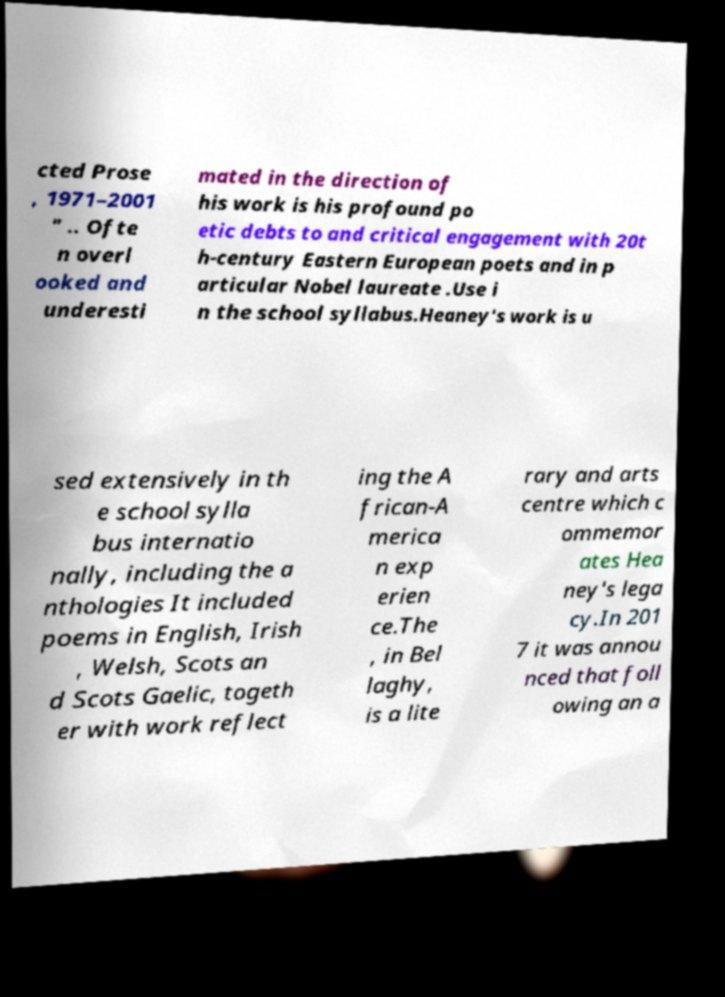Could you extract and type out the text from this image? cted Prose , 1971–2001 " .. Ofte n overl ooked and underesti mated in the direction of his work is his profound po etic debts to and critical engagement with 20t h-century Eastern European poets and in p articular Nobel laureate .Use i n the school syllabus.Heaney's work is u sed extensively in th e school sylla bus internatio nally, including the a nthologies It included poems in English, Irish , Welsh, Scots an d Scots Gaelic, togeth er with work reflect ing the A frican-A merica n exp erien ce.The , in Bel laghy, is a lite rary and arts centre which c ommemor ates Hea ney's lega cy.In 201 7 it was annou nced that foll owing an a 